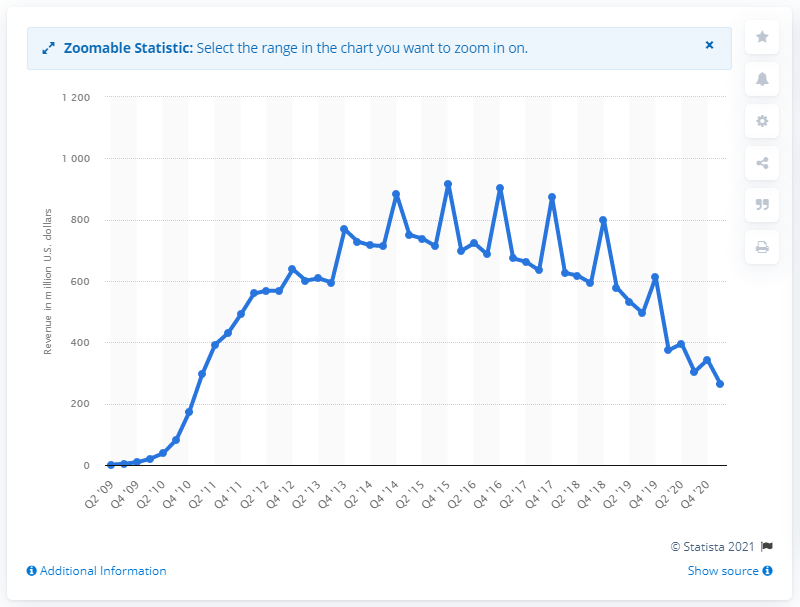Give some essential details in this illustration. Groupon's global revenue in the first quarter of 2021 was $263.82 million. 